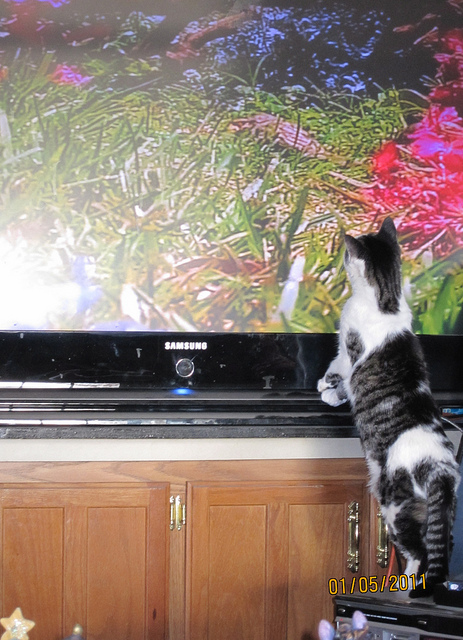Identify the text contained in this image. 01 05 /2011 SAMSUNG 